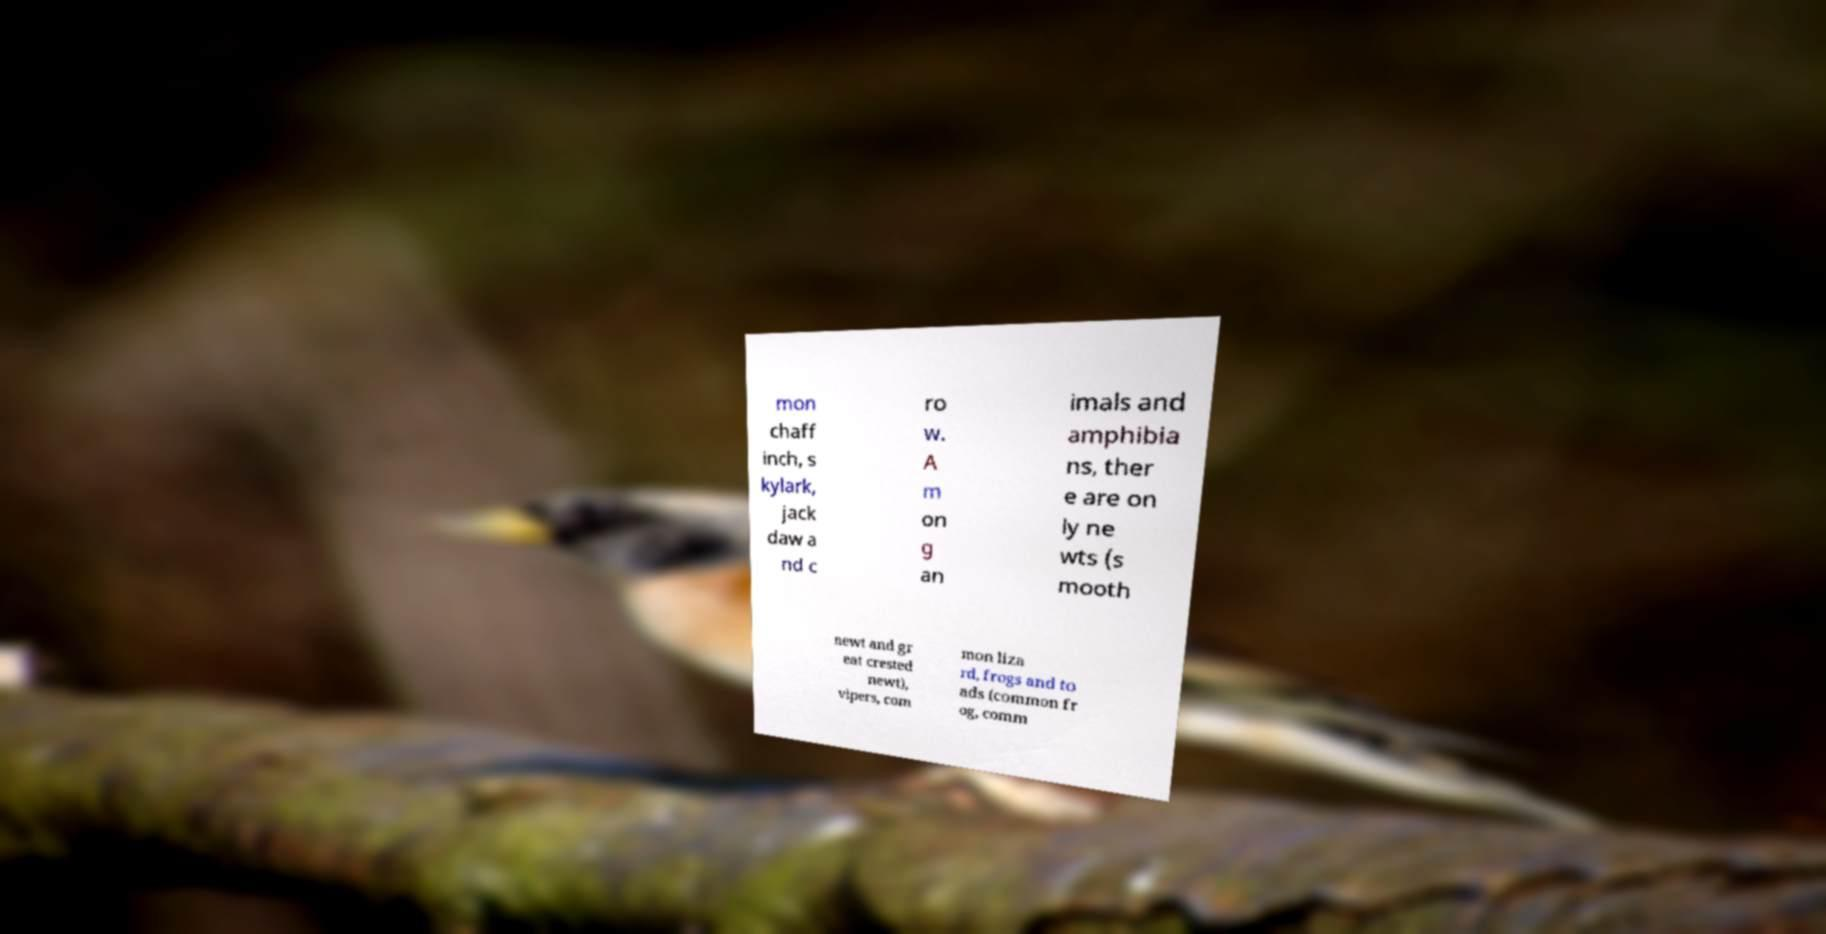Please identify and transcribe the text found in this image. mon chaff inch, s kylark, jack daw a nd c ro w. A m on g an imals and amphibia ns, ther e are on ly ne wts (s mooth newt and gr eat crested newt), vipers, com mon liza rd, frogs and to ads (common fr og, comm 